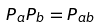Convert formula to latex. <formula><loc_0><loc_0><loc_500><loc_500>P _ { a } P _ { b } = P _ { a b }</formula> 